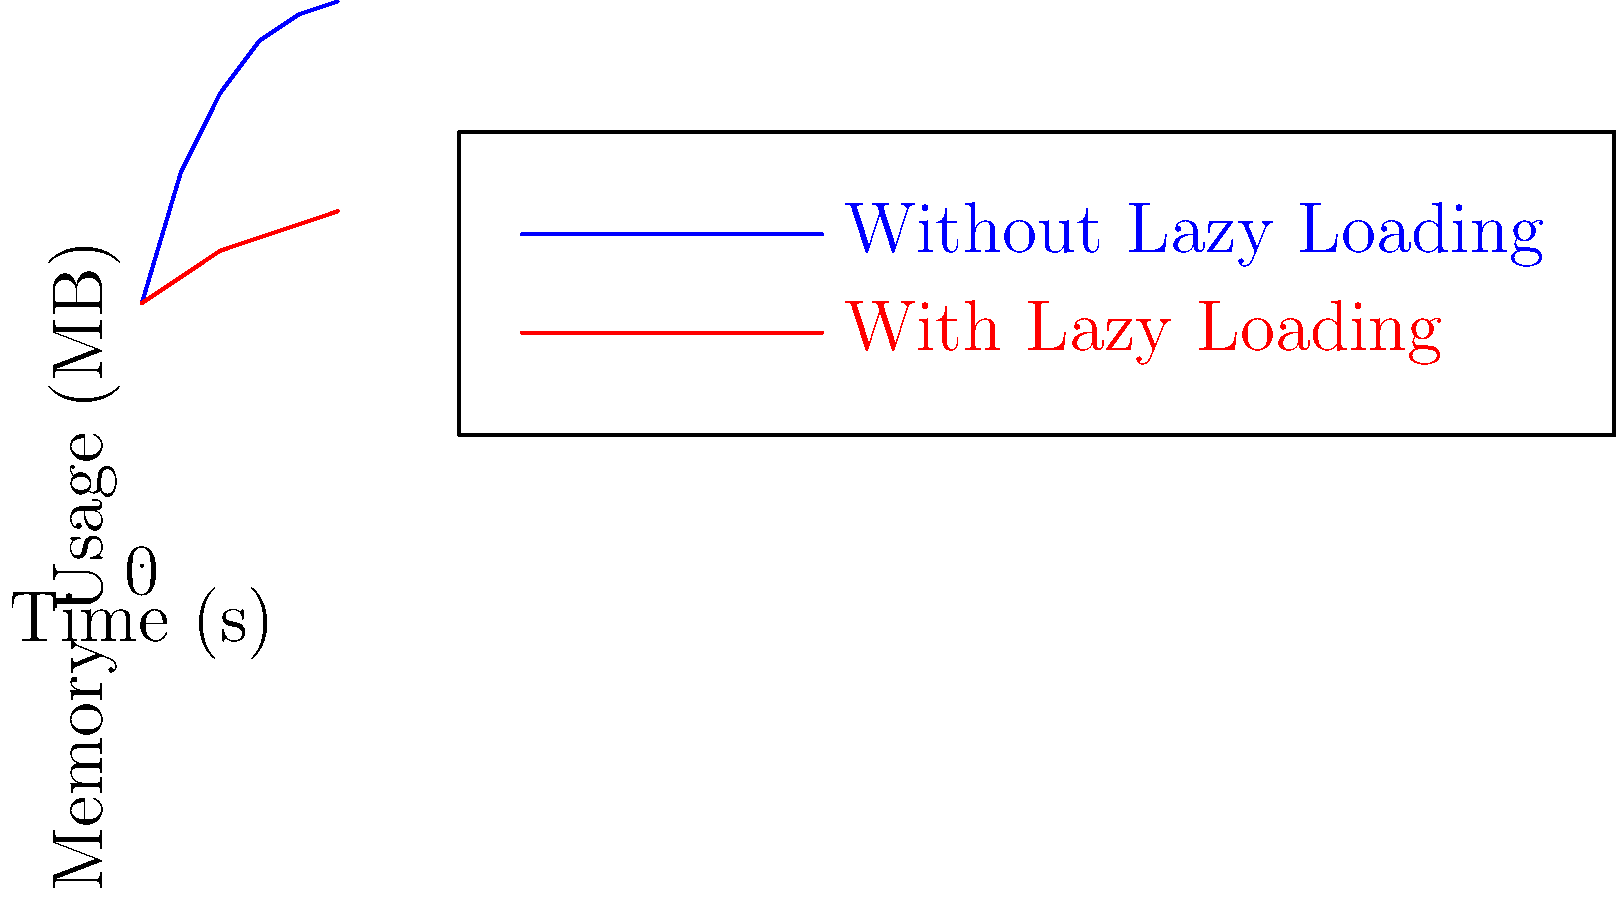Based on the memory usage graph shown, which implementation strategy for a custom Preference Screen in Android would result in better performance and lower memory consumption over time? To answer this question, let's analyze the graph and understand the implications of each line:

1. Blue line (Without Lazy Loading):
   - Shows a steep initial increase in memory usage
   - Reaches a higher peak memory usage (around 215 MB)
   - Memory usage continues to grow over time, albeit at a slower rate

2. Red line (With Lazy Loading):
   - Shows a gradual increase in memory usage
   - Reaches a lower peak memory usage (around 135 MB)
   - Memory usage stabilizes more quickly and remains relatively constant

3. Lazy Loading in Preference Screens:
   - Lazy loading is a technique where preferences are loaded only when needed
   - This reduces initial load time and memory consumption
   - It's particularly useful for large preference screens with many items

4. Performance Implications:
   - Lower memory usage generally leads to better performance
   - Less memory consumption reduces the likelihood of garbage collection events
   - Stable memory usage over time indicates better resource management

5. User Experience:
   - Faster initial load times with lazy loading improve user experience
   - Consistent performance over time enhances overall app responsiveness

Given these observations, the implementation strategy using lazy loading (represented by the red line) would result in better performance and lower memory consumption over time for a custom Preference Screen in Android.
Answer: Lazy loading implementation 